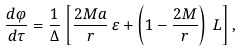<formula> <loc_0><loc_0><loc_500><loc_500>\frac { d \varphi } { d \tau } = \frac { 1 } { \Delta } \left [ \frac { 2 M a } { r } \, \varepsilon + \left ( 1 - \frac { 2 M } { r } \right ) \, L \right ] ,</formula> 